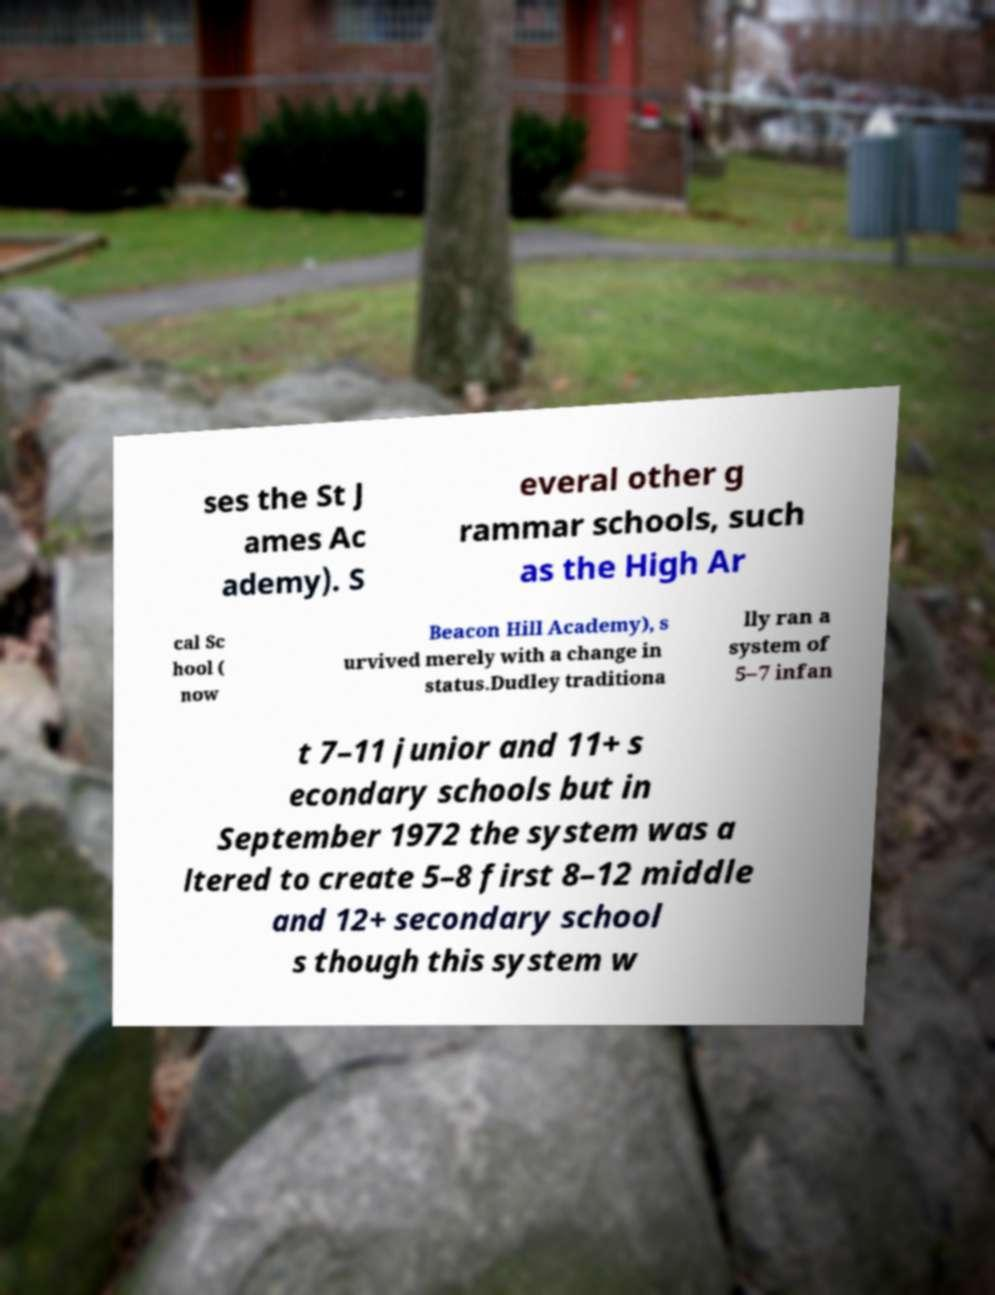Can you read and provide the text displayed in the image?This photo seems to have some interesting text. Can you extract and type it out for me? ses the St J ames Ac ademy). S everal other g rammar schools, such as the High Ar cal Sc hool ( now Beacon Hill Academy), s urvived merely with a change in status.Dudley traditiona lly ran a system of 5–7 infan t 7–11 junior and 11+ s econdary schools but in September 1972 the system was a ltered to create 5–8 first 8–12 middle and 12+ secondary school s though this system w 